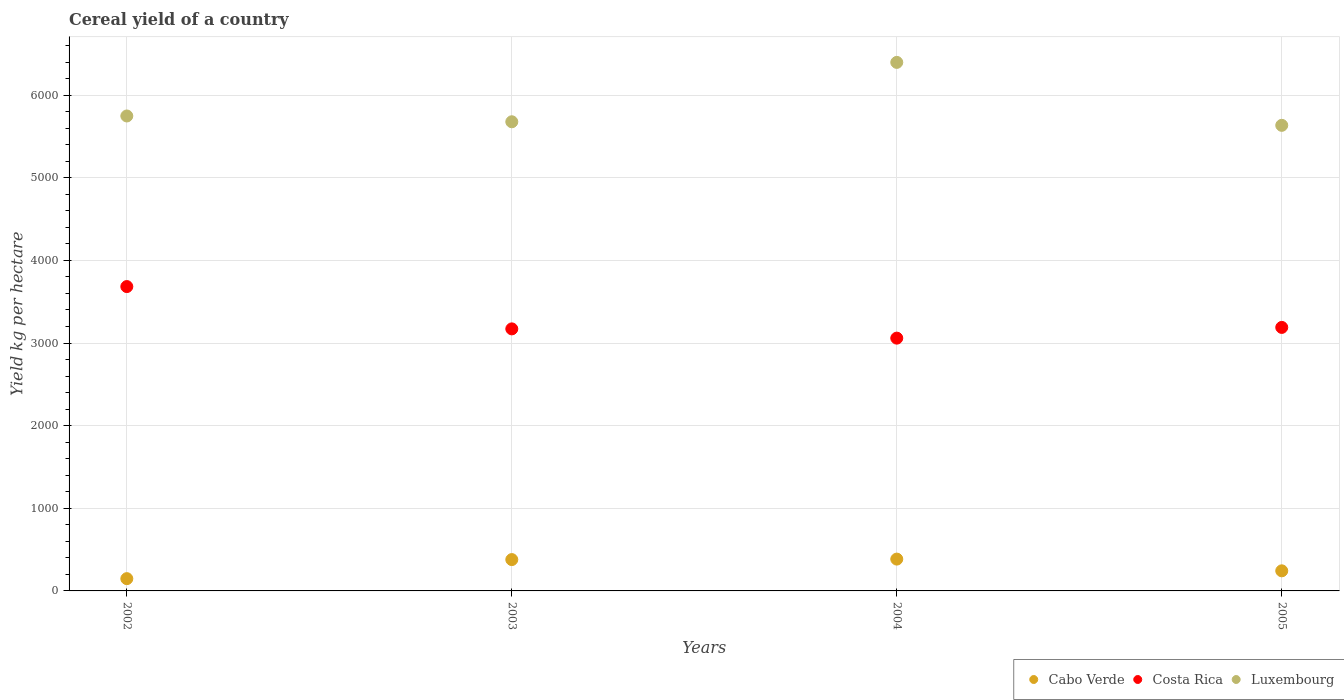How many different coloured dotlines are there?
Your answer should be compact. 3. Is the number of dotlines equal to the number of legend labels?
Offer a very short reply. Yes. What is the total cereal yield in Costa Rica in 2003?
Ensure brevity in your answer.  3171.38. Across all years, what is the maximum total cereal yield in Luxembourg?
Give a very brief answer. 6396.63. Across all years, what is the minimum total cereal yield in Luxembourg?
Your answer should be very brief. 5634.79. What is the total total cereal yield in Luxembourg in the graph?
Offer a very short reply. 2.35e+04. What is the difference between the total cereal yield in Cabo Verde in 2002 and that in 2003?
Your answer should be very brief. -230.69. What is the difference between the total cereal yield in Costa Rica in 2004 and the total cereal yield in Cabo Verde in 2005?
Give a very brief answer. 2816.16. What is the average total cereal yield in Cabo Verde per year?
Offer a very short reply. 289.01. In the year 2005, what is the difference between the total cereal yield in Cabo Verde and total cereal yield in Luxembourg?
Ensure brevity in your answer.  -5391.59. In how many years, is the total cereal yield in Luxembourg greater than 2800 kg per hectare?
Offer a very short reply. 4. What is the ratio of the total cereal yield in Cabo Verde in 2003 to that in 2005?
Your answer should be very brief. 1.56. Is the difference between the total cereal yield in Cabo Verde in 2002 and 2005 greater than the difference between the total cereal yield in Luxembourg in 2002 and 2005?
Your answer should be very brief. No. What is the difference between the highest and the second highest total cereal yield in Luxembourg?
Keep it short and to the point. 648.6. What is the difference between the highest and the lowest total cereal yield in Luxembourg?
Offer a terse response. 761.84. Is the total cereal yield in Cabo Verde strictly greater than the total cereal yield in Costa Rica over the years?
Ensure brevity in your answer.  No. How many dotlines are there?
Offer a terse response. 3. What is the difference between two consecutive major ticks on the Y-axis?
Give a very brief answer. 1000. Where does the legend appear in the graph?
Keep it short and to the point. Bottom right. What is the title of the graph?
Provide a succinct answer. Cereal yield of a country. Does "Turkmenistan" appear as one of the legend labels in the graph?
Provide a succinct answer. No. What is the label or title of the X-axis?
Provide a short and direct response. Years. What is the label or title of the Y-axis?
Your response must be concise. Yield kg per hectare. What is the Yield kg per hectare in Cabo Verde in 2002?
Your answer should be very brief. 148.5. What is the Yield kg per hectare in Costa Rica in 2002?
Ensure brevity in your answer.  3683.4. What is the Yield kg per hectare in Luxembourg in 2002?
Make the answer very short. 5748.03. What is the Yield kg per hectare in Cabo Verde in 2003?
Give a very brief answer. 379.18. What is the Yield kg per hectare in Costa Rica in 2003?
Make the answer very short. 3171.38. What is the Yield kg per hectare of Luxembourg in 2003?
Make the answer very short. 5677.96. What is the Yield kg per hectare of Cabo Verde in 2004?
Offer a terse response. 385.16. What is the Yield kg per hectare in Costa Rica in 2004?
Provide a short and direct response. 3059.36. What is the Yield kg per hectare of Luxembourg in 2004?
Make the answer very short. 6396.63. What is the Yield kg per hectare in Cabo Verde in 2005?
Offer a terse response. 243.2. What is the Yield kg per hectare of Costa Rica in 2005?
Give a very brief answer. 3189.15. What is the Yield kg per hectare of Luxembourg in 2005?
Give a very brief answer. 5634.79. Across all years, what is the maximum Yield kg per hectare in Cabo Verde?
Your answer should be compact. 385.16. Across all years, what is the maximum Yield kg per hectare of Costa Rica?
Your answer should be compact. 3683.4. Across all years, what is the maximum Yield kg per hectare in Luxembourg?
Your answer should be very brief. 6396.63. Across all years, what is the minimum Yield kg per hectare of Cabo Verde?
Your response must be concise. 148.5. Across all years, what is the minimum Yield kg per hectare of Costa Rica?
Your response must be concise. 3059.36. Across all years, what is the minimum Yield kg per hectare of Luxembourg?
Make the answer very short. 5634.79. What is the total Yield kg per hectare of Cabo Verde in the graph?
Ensure brevity in your answer.  1156.05. What is the total Yield kg per hectare of Costa Rica in the graph?
Your answer should be compact. 1.31e+04. What is the total Yield kg per hectare in Luxembourg in the graph?
Keep it short and to the point. 2.35e+04. What is the difference between the Yield kg per hectare of Cabo Verde in 2002 and that in 2003?
Make the answer very short. -230.69. What is the difference between the Yield kg per hectare of Costa Rica in 2002 and that in 2003?
Provide a succinct answer. 512.02. What is the difference between the Yield kg per hectare of Luxembourg in 2002 and that in 2003?
Keep it short and to the point. 70.07. What is the difference between the Yield kg per hectare in Cabo Verde in 2002 and that in 2004?
Your answer should be compact. -236.67. What is the difference between the Yield kg per hectare in Costa Rica in 2002 and that in 2004?
Give a very brief answer. 624.04. What is the difference between the Yield kg per hectare of Luxembourg in 2002 and that in 2004?
Your response must be concise. -648.6. What is the difference between the Yield kg per hectare of Cabo Verde in 2002 and that in 2005?
Provide a succinct answer. -94.7. What is the difference between the Yield kg per hectare in Costa Rica in 2002 and that in 2005?
Keep it short and to the point. 494.26. What is the difference between the Yield kg per hectare of Luxembourg in 2002 and that in 2005?
Ensure brevity in your answer.  113.24. What is the difference between the Yield kg per hectare in Cabo Verde in 2003 and that in 2004?
Make the answer very short. -5.98. What is the difference between the Yield kg per hectare of Costa Rica in 2003 and that in 2004?
Your answer should be compact. 112.02. What is the difference between the Yield kg per hectare in Luxembourg in 2003 and that in 2004?
Make the answer very short. -718.67. What is the difference between the Yield kg per hectare of Cabo Verde in 2003 and that in 2005?
Your answer should be compact. 135.98. What is the difference between the Yield kg per hectare of Costa Rica in 2003 and that in 2005?
Ensure brevity in your answer.  -17.77. What is the difference between the Yield kg per hectare in Luxembourg in 2003 and that in 2005?
Your answer should be compact. 43.17. What is the difference between the Yield kg per hectare of Cabo Verde in 2004 and that in 2005?
Your answer should be compact. 141.96. What is the difference between the Yield kg per hectare of Costa Rica in 2004 and that in 2005?
Offer a very short reply. -129.79. What is the difference between the Yield kg per hectare of Luxembourg in 2004 and that in 2005?
Your response must be concise. 761.84. What is the difference between the Yield kg per hectare in Cabo Verde in 2002 and the Yield kg per hectare in Costa Rica in 2003?
Make the answer very short. -3022.88. What is the difference between the Yield kg per hectare of Cabo Verde in 2002 and the Yield kg per hectare of Luxembourg in 2003?
Give a very brief answer. -5529.46. What is the difference between the Yield kg per hectare in Costa Rica in 2002 and the Yield kg per hectare in Luxembourg in 2003?
Make the answer very short. -1994.55. What is the difference between the Yield kg per hectare in Cabo Verde in 2002 and the Yield kg per hectare in Costa Rica in 2004?
Your response must be concise. -2910.86. What is the difference between the Yield kg per hectare of Cabo Verde in 2002 and the Yield kg per hectare of Luxembourg in 2004?
Offer a very short reply. -6248.13. What is the difference between the Yield kg per hectare of Costa Rica in 2002 and the Yield kg per hectare of Luxembourg in 2004?
Offer a terse response. -2713.22. What is the difference between the Yield kg per hectare in Cabo Verde in 2002 and the Yield kg per hectare in Costa Rica in 2005?
Give a very brief answer. -3040.65. What is the difference between the Yield kg per hectare of Cabo Verde in 2002 and the Yield kg per hectare of Luxembourg in 2005?
Provide a short and direct response. -5486.29. What is the difference between the Yield kg per hectare in Costa Rica in 2002 and the Yield kg per hectare in Luxembourg in 2005?
Make the answer very short. -1951.39. What is the difference between the Yield kg per hectare in Cabo Verde in 2003 and the Yield kg per hectare in Costa Rica in 2004?
Ensure brevity in your answer.  -2680.18. What is the difference between the Yield kg per hectare in Cabo Verde in 2003 and the Yield kg per hectare in Luxembourg in 2004?
Offer a very short reply. -6017.44. What is the difference between the Yield kg per hectare of Costa Rica in 2003 and the Yield kg per hectare of Luxembourg in 2004?
Provide a short and direct response. -3225.25. What is the difference between the Yield kg per hectare of Cabo Verde in 2003 and the Yield kg per hectare of Costa Rica in 2005?
Ensure brevity in your answer.  -2809.96. What is the difference between the Yield kg per hectare in Cabo Verde in 2003 and the Yield kg per hectare in Luxembourg in 2005?
Provide a succinct answer. -5255.61. What is the difference between the Yield kg per hectare in Costa Rica in 2003 and the Yield kg per hectare in Luxembourg in 2005?
Keep it short and to the point. -2463.41. What is the difference between the Yield kg per hectare of Cabo Verde in 2004 and the Yield kg per hectare of Costa Rica in 2005?
Ensure brevity in your answer.  -2803.98. What is the difference between the Yield kg per hectare of Cabo Verde in 2004 and the Yield kg per hectare of Luxembourg in 2005?
Your answer should be compact. -5249.63. What is the difference between the Yield kg per hectare in Costa Rica in 2004 and the Yield kg per hectare in Luxembourg in 2005?
Ensure brevity in your answer.  -2575.43. What is the average Yield kg per hectare of Cabo Verde per year?
Offer a very short reply. 289.01. What is the average Yield kg per hectare in Costa Rica per year?
Provide a succinct answer. 3275.82. What is the average Yield kg per hectare of Luxembourg per year?
Offer a terse response. 5864.35. In the year 2002, what is the difference between the Yield kg per hectare in Cabo Verde and Yield kg per hectare in Costa Rica?
Give a very brief answer. -3534.91. In the year 2002, what is the difference between the Yield kg per hectare in Cabo Verde and Yield kg per hectare in Luxembourg?
Make the answer very short. -5599.53. In the year 2002, what is the difference between the Yield kg per hectare of Costa Rica and Yield kg per hectare of Luxembourg?
Your answer should be compact. -2064.62. In the year 2003, what is the difference between the Yield kg per hectare of Cabo Verde and Yield kg per hectare of Costa Rica?
Offer a terse response. -2792.2. In the year 2003, what is the difference between the Yield kg per hectare of Cabo Verde and Yield kg per hectare of Luxembourg?
Your response must be concise. -5298.77. In the year 2003, what is the difference between the Yield kg per hectare of Costa Rica and Yield kg per hectare of Luxembourg?
Give a very brief answer. -2506.58. In the year 2004, what is the difference between the Yield kg per hectare of Cabo Verde and Yield kg per hectare of Costa Rica?
Offer a very short reply. -2674.2. In the year 2004, what is the difference between the Yield kg per hectare of Cabo Verde and Yield kg per hectare of Luxembourg?
Offer a very short reply. -6011.46. In the year 2004, what is the difference between the Yield kg per hectare in Costa Rica and Yield kg per hectare in Luxembourg?
Your answer should be compact. -3337.26. In the year 2005, what is the difference between the Yield kg per hectare in Cabo Verde and Yield kg per hectare in Costa Rica?
Offer a very short reply. -2945.95. In the year 2005, what is the difference between the Yield kg per hectare in Cabo Verde and Yield kg per hectare in Luxembourg?
Make the answer very short. -5391.59. In the year 2005, what is the difference between the Yield kg per hectare of Costa Rica and Yield kg per hectare of Luxembourg?
Provide a short and direct response. -2445.64. What is the ratio of the Yield kg per hectare of Cabo Verde in 2002 to that in 2003?
Your response must be concise. 0.39. What is the ratio of the Yield kg per hectare of Costa Rica in 2002 to that in 2003?
Your answer should be compact. 1.16. What is the ratio of the Yield kg per hectare of Luxembourg in 2002 to that in 2003?
Offer a very short reply. 1.01. What is the ratio of the Yield kg per hectare of Cabo Verde in 2002 to that in 2004?
Your response must be concise. 0.39. What is the ratio of the Yield kg per hectare in Costa Rica in 2002 to that in 2004?
Ensure brevity in your answer.  1.2. What is the ratio of the Yield kg per hectare of Luxembourg in 2002 to that in 2004?
Your answer should be compact. 0.9. What is the ratio of the Yield kg per hectare of Cabo Verde in 2002 to that in 2005?
Offer a very short reply. 0.61. What is the ratio of the Yield kg per hectare of Costa Rica in 2002 to that in 2005?
Ensure brevity in your answer.  1.16. What is the ratio of the Yield kg per hectare of Luxembourg in 2002 to that in 2005?
Keep it short and to the point. 1.02. What is the ratio of the Yield kg per hectare of Cabo Verde in 2003 to that in 2004?
Keep it short and to the point. 0.98. What is the ratio of the Yield kg per hectare of Costa Rica in 2003 to that in 2004?
Offer a very short reply. 1.04. What is the ratio of the Yield kg per hectare of Luxembourg in 2003 to that in 2004?
Your answer should be compact. 0.89. What is the ratio of the Yield kg per hectare of Cabo Verde in 2003 to that in 2005?
Offer a terse response. 1.56. What is the ratio of the Yield kg per hectare of Costa Rica in 2003 to that in 2005?
Make the answer very short. 0.99. What is the ratio of the Yield kg per hectare of Luxembourg in 2003 to that in 2005?
Offer a very short reply. 1.01. What is the ratio of the Yield kg per hectare in Cabo Verde in 2004 to that in 2005?
Provide a short and direct response. 1.58. What is the ratio of the Yield kg per hectare of Costa Rica in 2004 to that in 2005?
Offer a terse response. 0.96. What is the ratio of the Yield kg per hectare in Luxembourg in 2004 to that in 2005?
Your answer should be compact. 1.14. What is the difference between the highest and the second highest Yield kg per hectare in Cabo Verde?
Provide a short and direct response. 5.98. What is the difference between the highest and the second highest Yield kg per hectare of Costa Rica?
Offer a terse response. 494.26. What is the difference between the highest and the second highest Yield kg per hectare in Luxembourg?
Your response must be concise. 648.6. What is the difference between the highest and the lowest Yield kg per hectare of Cabo Verde?
Make the answer very short. 236.67. What is the difference between the highest and the lowest Yield kg per hectare in Costa Rica?
Your answer should be compact. 624.04. What is the difference between the highest and the lowest Yield kg per hectare of Luxembourg?
Provide a short and direct response. 761.84. 